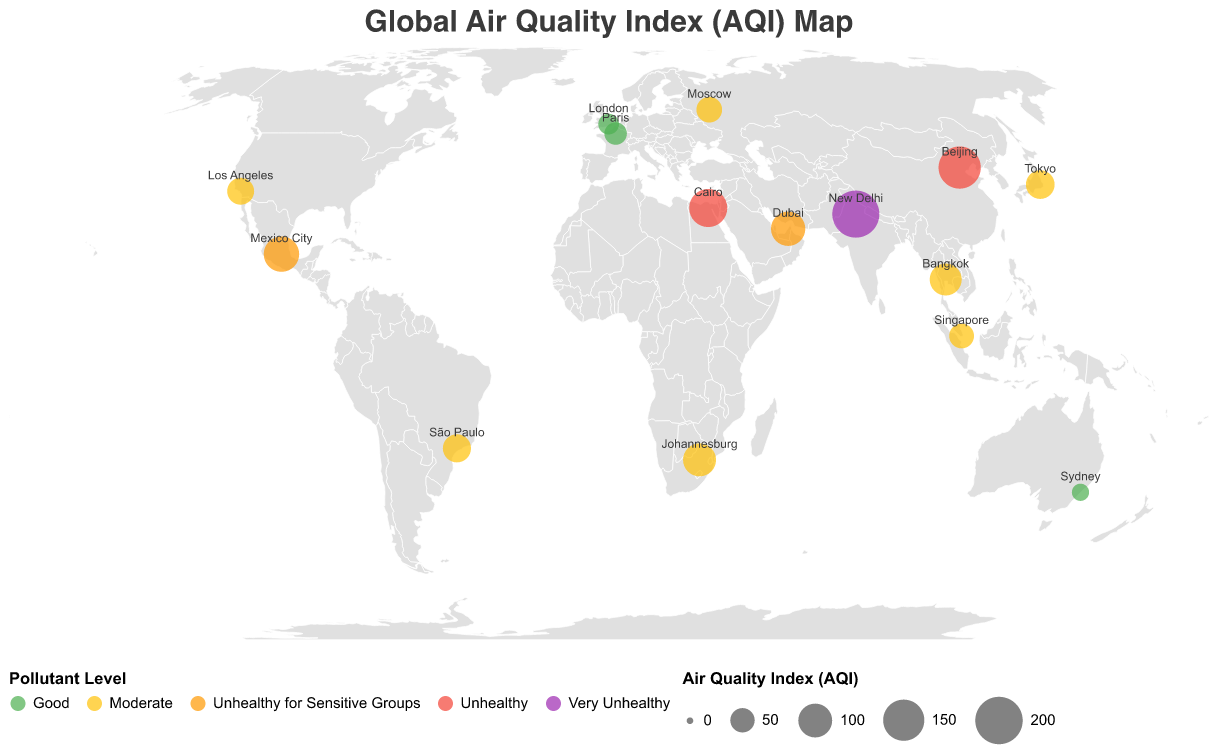What city has the highest Air Quality Index (AQI)? Looking at the circle sizes on the map, the largest circle corresponds to the highest AQI, which is for New Delhi with an AQI of 197.
Answer: New Delhi Which cities have a Pollutant Level of "Good"? Circles colored with the color associated with "Good" are Sydney, London, and Paris.
Answer: Sydney, London, Paris What is the Pollutant Level of Beijing? By finding Beijing on the map, its corresponding color indicates the Pollutant Level as "Unhealthy".
Answer: Unhealthy How many cities have an AQI classified as "Moderate"? The moderate AQI classification includes the circles of medium size with a specific color, representing Los Angeles, Bangkok, Moscow, Singapore, Tokyo, São Paulo, and Johannesburg.
Answer: 7 Compare the AQI of Mexico City and Cairo. Which city has a higher AQI? Locate both cities and compare the sizes of the circles. Cairo has a higher AQI of 128 compared to Mexico City with an AQI of 110.
Answer: Cairo What is the Health Impact of the city with the lowest AQI shown on the map? Identify Sydney as the city with the lowest AQI of 23, which has corresponding Health Impact data listed as "Low".
Answer: Low Which continent has the highest average AQI among its cities represented on the map? Sum the AQI values for cities in each continent and divide by the number of cities to find the average. Asia has Beijing (158), New Delhi (197), and Bangkok (89), giving an average of (158 + 197 + 89) / 3 = 148.
Answer: Asia How does the Pollutant Level of Dubai compare to that of Singapore? The circles' colors show that Dubai is "Unhealthy for Sensitive Groups" while Singapore is "Moderate".
Answer: Higher Which cities have a "High" Health Impact but different Pollutant Levels? Check the Health Impact category and then look for different Pollutant Level colors. Beijing (Unhealthy), Mexico City (Unhealthy for Sensitive Groups), Cairo (Unhealthy), and Dubai (Unhealthy for Sensitive Groups) all have "High" Health Impact but different Pollutant Levels.
Answer: Beijing, Mexico City, Cairo, Dubai Identify two cities with an AQI between 50 and 70. Look for medium-sized circles corresponding to this AQI range and verify their values. Moscow has an AQI of 56, and São Paulo has an AQI of 68.
Answer: Moscow, São Paulo 